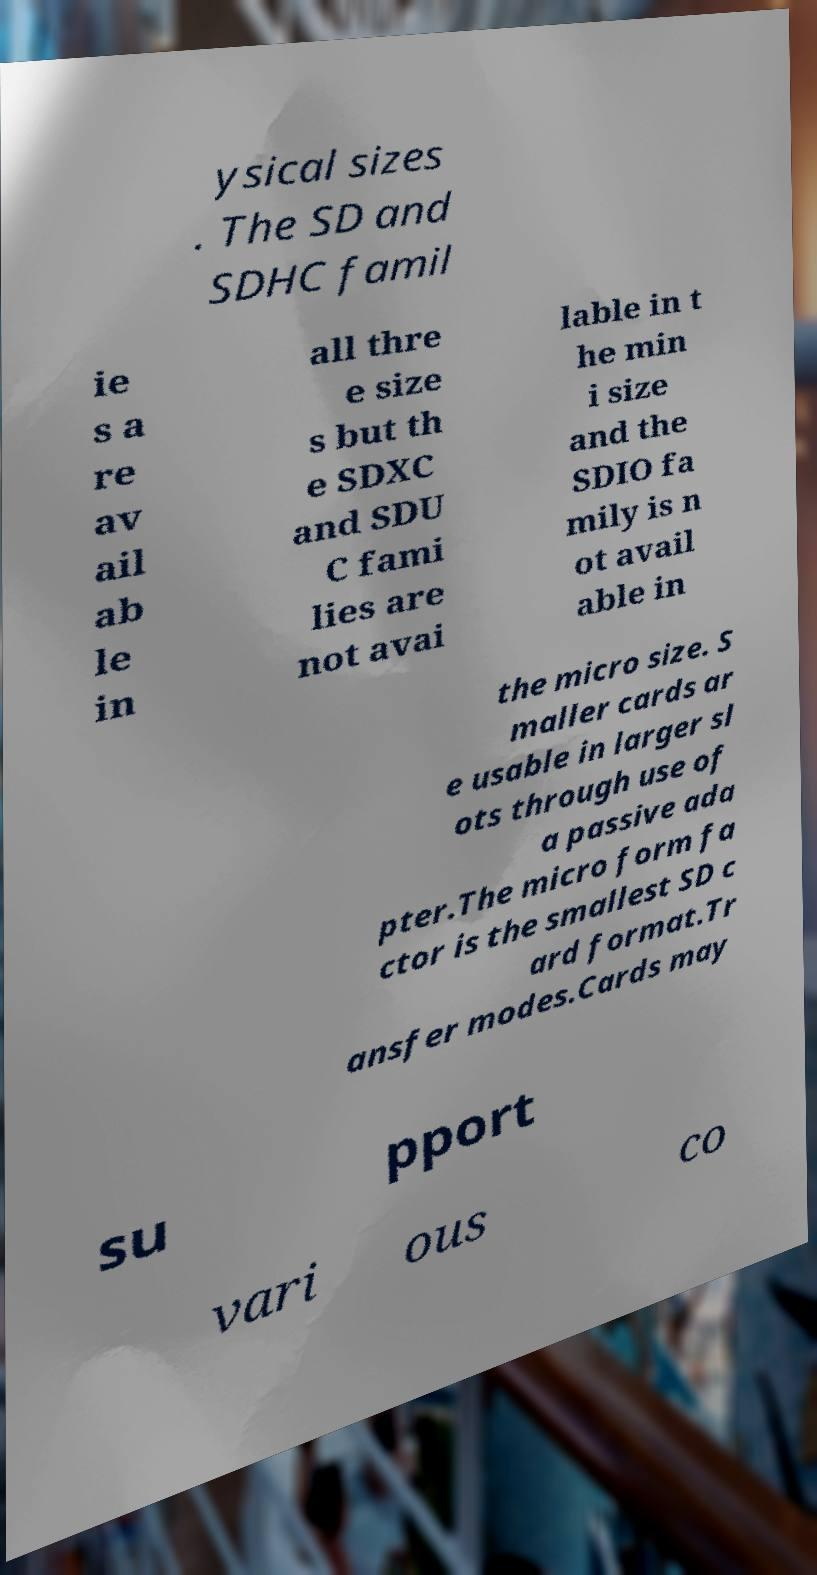There's text embedded in this image that I need extracted. Can you transcribe it verbatim? ysical sizes . The SD and SDHC famil ie s a re av ail ab le in all thre e size s but th e SDXC and SDU C fami lies are not avai lable in t he min i size and the SDIO fa mily is n ot avail able in the micro size. S maller cards ar e usable in larger sl ots through use of a passive ada pter.The micro form fa ctor is the smallest SD c ard format.Tr ansfer modes.Cards may su pport vari ous co 